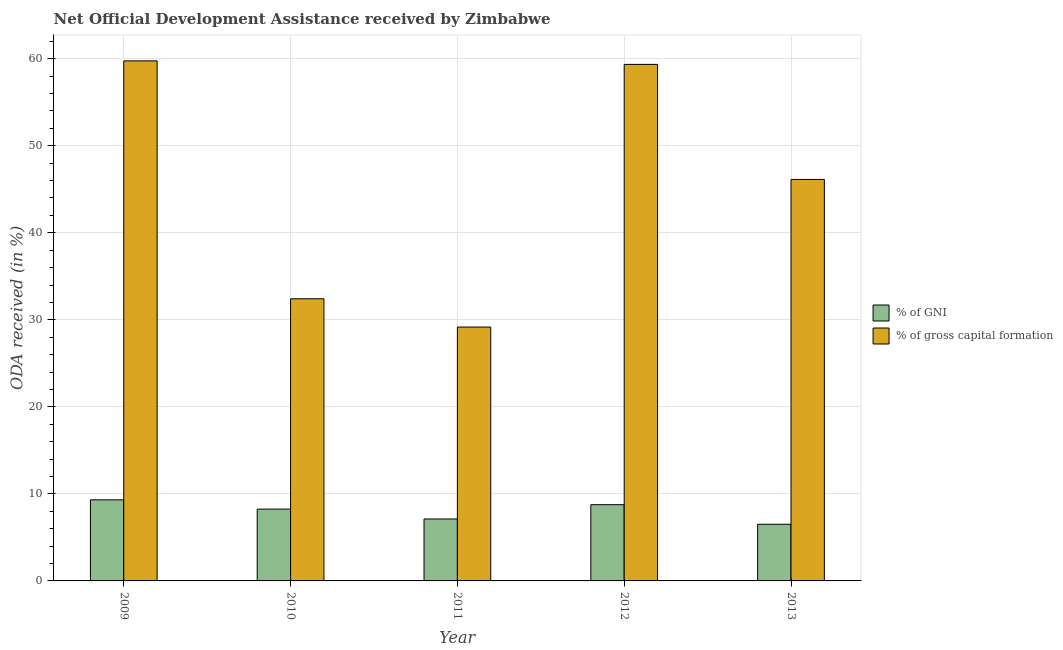How many different coloured bars are there?
Ensure brevity in your answer.  2. How many groups of bars are there?
Offer a terse response. 5. Are the number of bars on each tick of the X-axis equal?
Make the answer very short. Yes. How many bars are there on the 2nd tick from the left?
Provide a succinct answer. 2. What is the label of the 5th group of bars from the left?
Give a very brief answer. 2013. What is the oda received as percentage of gni in 2009?
Offer a very short reply. 9.32. Across all years, what is the maximum oda received as percentage of gross capital formation?
Your response must be concise. 59.75. Across all years, what is the minimum oda received as percentage of gni?
Your answer should be very brief. 6.51. In which year was the oda received as percentage of gross capital formation maximum?
Your answer should be compact. 2009. What is the total oda received as percentage of gross capital formation in the graph?
Keep it short and to the point. 226.82. What is the difference between the oda received as percentage of gross capital formation in 2011 and that in 2013?
Provide a short and direct response. -16.96. What is the difference between the oda received as percentage of gross capital formation in 2013 and the oda received as percentage of gni in 2010?
Provide a short and direct response. 13.71. What is the average oda received as percentage of gni per year?
Your response must be concise. 7.99. What is the ratio of the oda received as percentage of gni in 2010 to that in 2011?
Your answer should be very brief. 1.16. Is the oda received as percentage of gross capital formation in 2009 less than that in 2011?
Your response must be concise. No. Is the difference between the oda received as percentage of gni in 2009 and 2013 greater than the difference between the oda received as percentage of gross capital formation in 2009 and 2013?
Provide a succinct answer. No. What is the difference between the highest and the second highest oda received as percentage of gross capital formation?
Offer a very short reply. 0.41. What is the difference between the highest and the lowest oda received as percentage of gross capital formation?
Make the answer very short. 30.58. In how many years, is the oda received as percentage of gni greater than the average oda received as percentage of gni taken over all years?
Ensure brevity in your answer.  3. Is the sum of the oda received as percentage of gross capital formation in 2009 and 2011 greater than the maximum oda received as percentage of gni across all years?
Your answer should be compact. Yes. What does the 1st bar from the left in 2011 represents?
Your answer should be very brief. % of GNI. What does the 2nd bar from the right in 2011 represents?
Provide a succinct answer. % of GNI. How many bars are there?
Your response must be concise. 10. How many years are there in the graph?
Give a very brief answer. 5. Are the values on the major ticks of Y-axis written in scientific E-notation?
Give a very brief answer. No. Does the graph contain any zero values?
Your answer should be compact. No. Does the graph contain grids?
Offer a terse response. Yes. Where does the legend appear in the graph?
Offer a very short reply. Center right. What is the title of the graph?
Ensure brevity in your answer.  Net Official Development Assistance received by Zimbabwe. What is the label or title of the Y-axis?
Your response must be concise. ODA received (in %). What is the ODA received (in %) of % of GNI in 2009?
Your answer should be very brief. 9.32. What is the ODA received (in %) of % of gross capital formation in 2009?
Your response must be concise. 59.75. What is the ODA received (in %) in % of GNI in 2010?
Keep it short and to the point. 8.25. What is the ODA received (in %) of % of gross capital formation in 2010?
Provide a short and direct response. 32.42. What is the ODA received (in %) in % of GNI in 2011?
Offer a very short reply. 7.12. What is the ODA received (in %) in % of gross capital formation in 2011?
Your response must be concise. 29.17. What is the ODA received (in %) of % of GNI in 2012?
Your response must be concise. 8.76. What is the ODA received (in %) of % of gross capital formation in 2012?
Offer a very short reply. 59.35. What is the ODA received (in %) in % of GNI in 2013?
Ensure brevity in your answer.  6.51. What is the ODA received (in %) of % of gross capital formation in 2013?
Your answer should be very brief. 46.13. Across all years, what is the maximum ODA received (in %) of % of GNI?
Keep it short and to the point. 9.32. Across all years, what is the maximum ODA received (in %) of % of gross capital formation?
Offer a terse response. 59.75. Across all years, what is the minimum ODA received (in %) in % of GNI?
Your response must be concise. 6.51. Across all years, what is the minimum ODA received (in %) in % of gross capital formation?
Give a very brief answer. 29.17. What is the total ODA received (in %) in % of GNI in the graph?
Offer a very short reply. 39.96. What is the total ODA received (in %) of % of gross capital formation in the graph?
Make the answer very short. 226.82. What is the difference between the ODA received (in %) in % of GNI in 2009 and that in 2010?
Keep it short and to the point. 1.06. What is the difference between the ODA received (in %) in % of gross capital formation in 2009 and that in 2010?
Ensure brevity in your answer.  27.34. What is the difference between the ODA received (in %) of % of GNI in 2009 and that in 2011?
Provide a short and direct response. 2.2. What is the difference between the ODA received (in %) of % of gross capital formation in 2009 and that in 2011?
Offer a very short reply. 30.58. What is the difference between the ODA received (in %) in % of GNI in 2009 and that in 2012?
Make the answer very short. 0.56. What is the difference between the ODA received (in %) in % of gross capital formation in 2009 and that in 2012?
Make the answer very short. 0.41. What is the difference between the ODA received (in %) of % of GNI in 2009 and that in 2013?
Make the answer very short. 2.81. What is the difference between the ODA received (in %) in % of gross capital formation in 2009 and that in 2013?
Provide a succinct answer. 13.62. What is the difference between the ODA received (in %) in % of GNI in 2010 and that in 2011?
Keep it short and to the point. 1.13. What is the difference between the ODA received (in %) in % of gross capital formation in 2010 and that in 2011?
Provide a succinct answer. 3.25. What is the difference between the ODA received (in %) of % of GNI in 2010 and that in 2012?
Keep it short and to the point. -0.51. What is the difference between the ODA received (in %) in % of gross capital formation in 2010 and that in 2012?
Your answer should be compact. -26.93. What is the difference between the ODA received (in %) of % of GNI in 2010 and that in 2013?
Your answer should be compact. 1.74. What is the difference between the ODA received (in %) of % of gross capital formation in 2010 and that in 2013?
Offer a very short reply. -13.71. What is the difference between the ODA received (in %) of % of GNI in 2011 and that in 2012?
Offer a terse response. -1.64. What is the difference between the ODA received (in %) of % of gross capital formation in 2011 and that in 2012?
Give a very brief answer. -30.18. What is the difference between the ODA received (in %) in % of GNI in 2011 and that in 2013?
Give a very brief answer. 0.61. What is the difference between the ODA received (in %) of % of gross capital formation in 2011 and that in 2013?
Your answer should be very brief. -16.96. What is the difference between the ODA received (in %) of % of GNI in 2012 and that in 2013?
Provide a succinct answer. 2.25. What is the difference between the ODA received (in %) in % of gross capital formation in 2012 and that in 2013?
Provide a succinct answer. 13.22. What is the difference between the ODA received (in %) of % of GNI in 2009 and the ODA received (in %) of % of gross capital formation in 2010?
Ensure brevity in your answer.  -23.1. What is the difference between the ODA received (in %) of % of GNI in 2009 and the ODA received (in %) of % of gross capital formation in 2011?
Keep it short and to the point. -19.85. What is the difference between the ODA received (in %) of % of GNI in 2009 and the ODA received (in %) of % of gross capital formation in 2012?
Your response must be concise. -50.03. What is the difference between the ODA received (in %) in % of GNI in 2009 and the ODA received (in %) in % of gross capital formation in 2013?
Make the answer very short. -36.81. What is the difference between the ODA received (in %) of % of GNI in 2010 and the ODA received (in %) of % of gross capital formation in 2011?
Offer a terse response. -20.92. What is the difference between the ODA received (in %) in % of GNI in 2010 and the ODA received (in %) in % of gross capital formation in 2012?
Make the answer very short. -51.1. What is the difference between the ODA received (in %) of % of GNI in 2010 and the ODA received (in %) of % of gross capital formation in 2013?
Your answer should be very brief. -37.88. What is the difference between the ODA received (in %) of % of GNI in 2011 and the ODA received (in %) of % of gross capital formation in 2012?
Keep it short and to the point. -52.23. What is the difference between the ODA received (in %) in % of GNI in 2011 and the ODA received (in %) in % of gross capital formation in 2013?
Your answer should be compact. -39.01. What is the difference between the ODA received (in %) of % of GNI in 2012 and the ODA received (in %) of % of gross capital formation in 2013?
Offer a terse response. -37.37. What is the average ODA received (in %) of % of GNI per year?
Ensure brevity in your answer.  7.99. What is the average ODA received (in %) in % of gross capital formation per year?
Your response must be concise. 45.36. In the year 2009, what is the difference between the ODA received (in %) in % of GNI and ODA received (in %) in % of gross capital formation?
Ensure brevity in your answer.  -50.44. In the year 2010, what is the difference between the ODA received (in %) of % of GNI and ODA received (in %) of % of gross capital formation?
Make the answer very short. -24.17. In the year 2011, what is the difference between the ODA received (in %) of % of GNI and ODA received (in %) of % of gross capital formation?
Your response must be concise. -22.05. In the year 2012, what is the difference between the ODA received (in %) in % of GNI and ODA received (in %) in % of gross capital formation?
Your answer should be very brief. -50.59. In the year 2013, what is the difference between the ODA received (in %) in % of GNI and ODA received (in %) in % of gross capital formation?
Give a very brief answer. -39.62. What is the ratio of the ODA received (in %) of % of GNI in 2009 to that in 2010?
Ensure brevity in your answer.  1.13. What is the ratio of the ODA received (in %) of % of gross capital formation in 2009 to that in 2010?
Provide a succinct answer. 1.84. What is the ratio of the ODA received (in %) in % of GNI in 2009 to that in 2011?
Offer a terse response. 1.31. What is the ratio of the ODA received (in %) of % of gross capital formation in 2009 to that in 2011?
Offer a very short reply. 2.05. What is the ratio of the ODA received (in %) in % of GNI in 2009 to that in 2012?
Offer a terse response. 1.06. What is the ratio of the ODA received (in %) in % of gross capital formation in 2009 to that in 2012?
Keep it short and to the point. 1.01. What is the ratio of the ODA received (in %) of % of GNI in 2009 to that in 2013?
Your response must be concise. 1.43. What is the ratio of the ODA received (in %) of % of gross capital formation in 2009 to that in 2013?
Provide a succinct answer. 1.3. What is the ratio of the ODA received (in %) of % of GNI in 2010 to that in 2011?
Offer a terse response. 1.16. What is the ratio of the ODA received (in %) in % of gross capital formation in 2010 to that in 2011?
Provide a succinct answer. 1.11. What is the ratio of the ODA received (in %) in % of GNI in 2010 to that in 2012?
Make the answer very short. 0.94. What is the ratio of the ODA received (in %) in % of gross capital formation in 2010 to that in 2012?
Make the answer very short. 0.55. What is the ratio of the ODA received (in %) of % of GNI in 2010 to that in 2013?
Offer a terse response. 1.27. What is the ratio of the ODA received (in %) in % of gross capital formation in 2010 to that in 2013?
Your response must be concise. 0.7. What is the ratio of the ODA received (in %) in % of GNI in 2011 to that in 2012?
Offer a very short reply. 0.81. What is the ratio of the ODA received (in %) in % of gross capital formation in 2011 to that in 2012?
Keep it short and to the point. 0.49. What is the ratio of the ODA received (in %) in % of GNI in 2011 to that in 2013?
Your answer should be very brief. 1.09. What is the ratio of the ODA received (in %) of % of gross capital formation in 2011 to that in 2013?
Offer a terse response. 0.63. What is the ratio of the ODA received (in %) in % of GNI in 2012 to that in 2013?
Provide a short and direct response. 1.35. What is the ratio of the ODA received (in %) in % of gross capital formation in 2012 to that in 2013?
Keep it short and to the point. 1.29. What is the difference between the highest and the second highest ODA received (in %) of % of GNI?
Offer a terse response. 0.56. What is the difference between the highest and the second highest ODA received (in %) in % of gross capital formation?
Provide a succinct answer. 0.41. What is the difference between the highest and the lowest ODA received (in %) of % of GNI?
Offer a terse response. 2.81. What is the difference between the highest and the lowest ODA received (in %) in % of gross capital formation?
Your answer should be very brief. 30.58. 